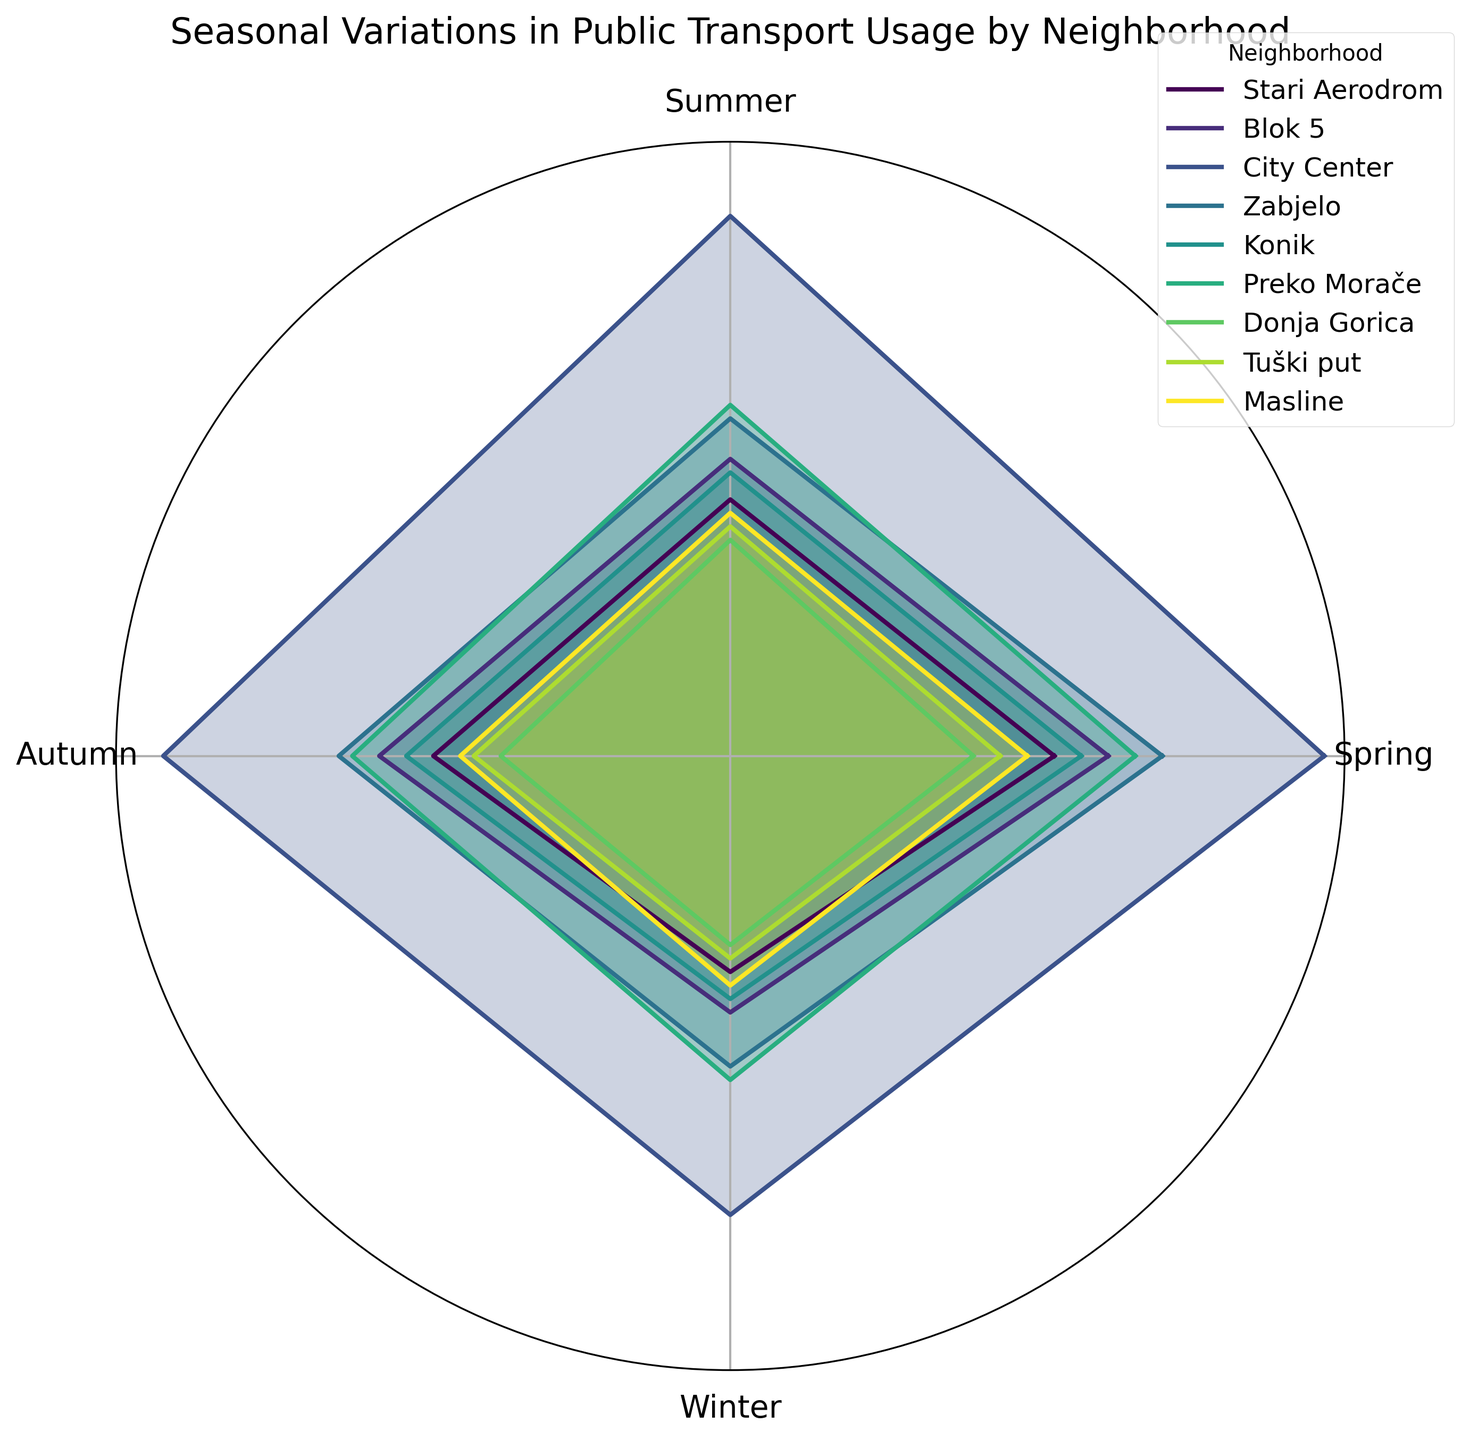How does the public transport usage in the City Center compare between Summer and Winter? Observing the figure, the line representing the City Center is higher in Summer than in Winter. This indicates that usage is greater in Summer.
Answer: It's higher in Summer Which neighborhood shows the smallest variation in public transport usage across the seasons? By comparing the visual spread of the lines for all neighborhoods, Donja Gorica lines appear the most even, indicating the least variation.
Answer: Donja Gorica What is the total public transport usage in Blok 5 across all seasons? From the figure, Blok 5's seasonal usage is Spring (1400), Summer (1100), Autumn (1300), Winter (950). Summing these values: 1400 + 1100 + 1300 + 950 = 4750.
Answer: 4750 What season experiences the highest overall public transport usage in Podgorica? By summing up the usage of all neighborhoods for each season, Spring has the highest lines, indicating the highest usage. Adding values for Spring: 1200 + 1400 + 2200 + 1600 + 1300 + 1500 + 900 + 1000 + 1100 = 12100.
Answer: Spring Comparing Zabjelo and Konik, which neighborhood exhibits a larger decrease in public transport usage from Spring to Winter? Zabjelo decreases from 1600 to 1150, a decrease of 450. Konik decreases from 1300 to 900, a decrease of 400.
Answer: Zabjelo Which neighborhood has the highest public transport usage in Autumn? In the figure, the line for "City Center" is the outermost in Autumn, indicating the highest usage.
Answer: City Center How much does public transport usage increase in Tuški put from Winter to Spring? Tuški put's usage increases from 750 in Winter to 1000 in Spring. The increase is 1000 - 750 = 250.
Answer: 250 Is the public transport usage higher in Summer or Autumn for Preko Morače? From the figure, Preko Morače has higher usage in Autumn compared to Summer.
Answer: Autumn What is the average public transport usage for Stari Aerodrom across all seasons? Stari Aerodrom's usage is: Spring (1200), Summer (950), Autumn (1100), Winter (800). The average is (1200 + 950 + 1100 + 800) / 4 = 1012.5.
Answer: 1012.5 Which neighborhoods show a noticeable decrease in public transport usage in Summer compared to Spring? By comparing the visual lengths, "Stari Aerodrom," "Blok 5," "City Center," "Zabjelo," "Konik," "Preko Morače," "Donja Gorica," "Tuški put," and "Masline" all have shorter lines in Summer than in Spring, indicating a decrease.
Answer: Stari Aerodrom, Blok 5, City Center, Zabjelo, Konik, Preko Morače, Donja Gorica, Tuški put, Masline 